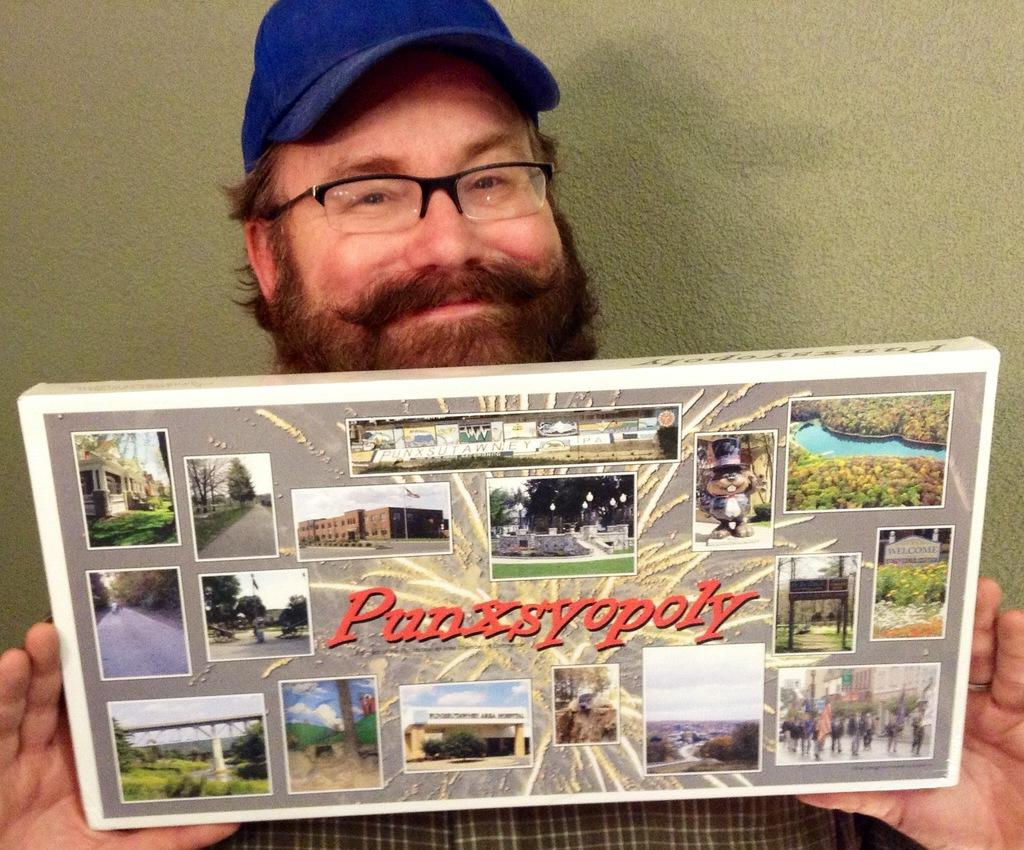What is the man in the image doing with his hands? The man is holding a frame with his hands. What can be seen on the man's face? The man has spectacles and is smiling. What is visible in the background of the image? There is a wall in the background of the image. What type of cream is being applied to the man's face in the image? There is no cream being applied to the man's face in the image. How many pages can be seen in the man's hands in the image? There are no pages present in the image; the man is holding a frame. 